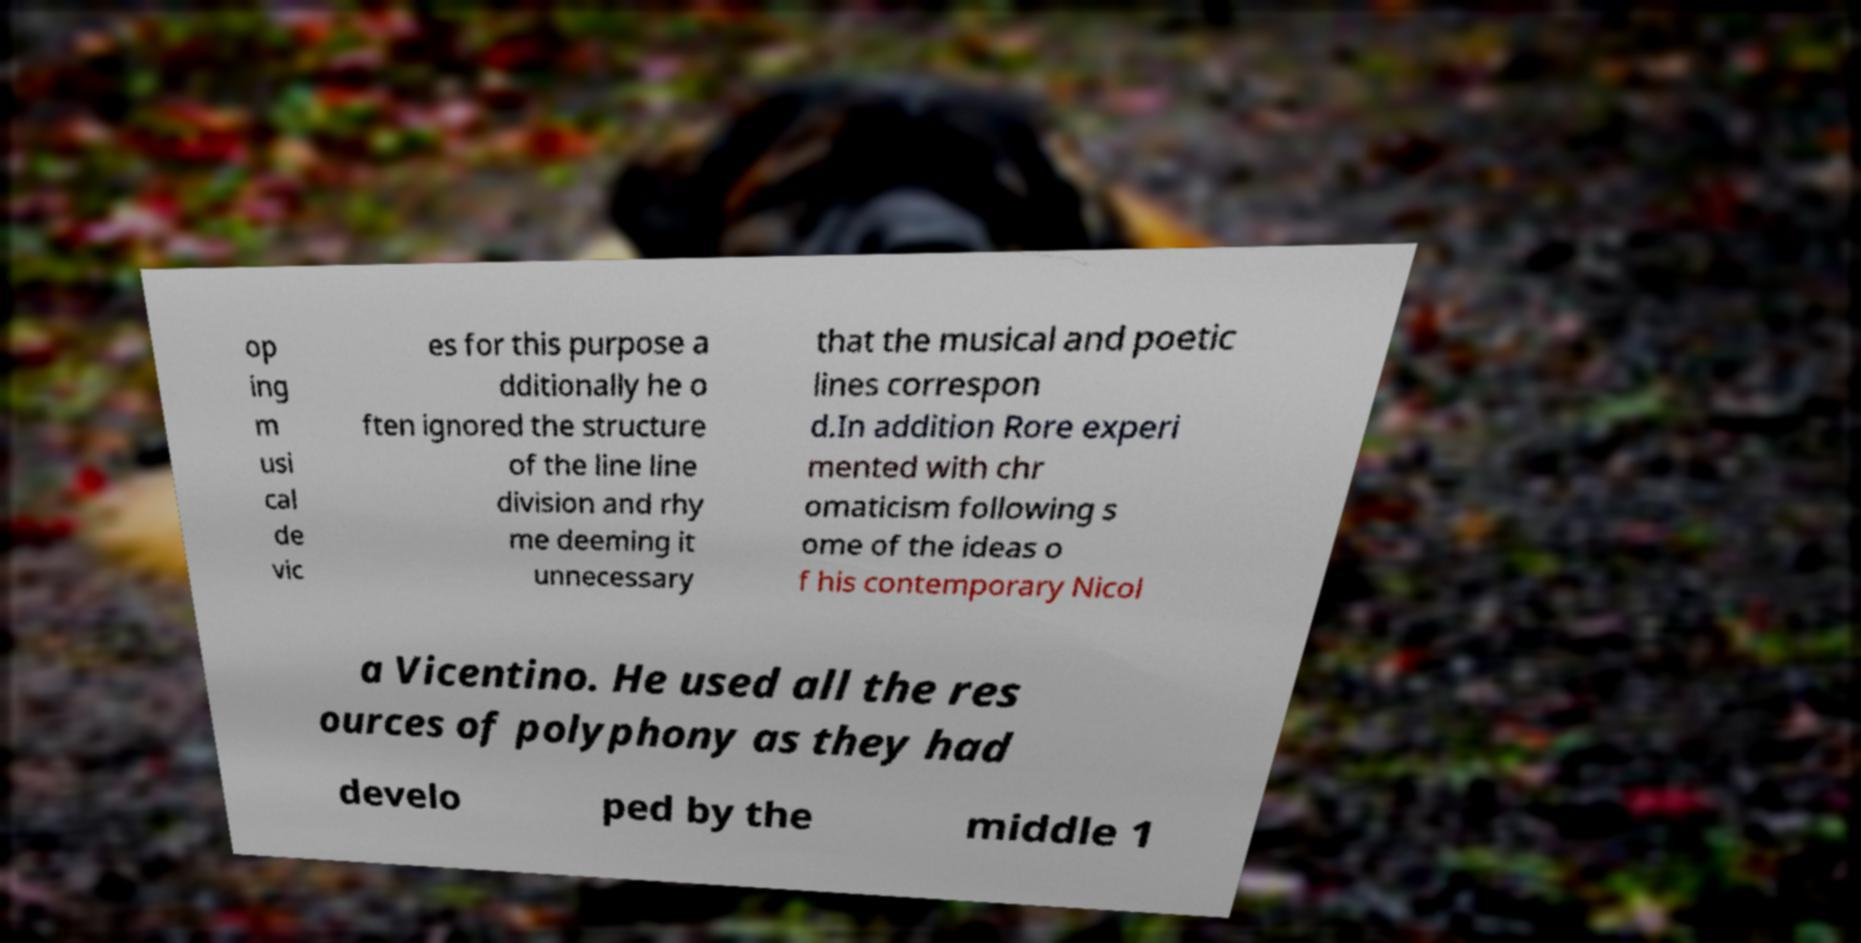What messages or text are displayed in this image? I need them in a readable, typed format. op ing m usi cal de vic es for this purpose a dditionally he o ften ignored the structure of the line line division and rhy me deeming it unnecessary that the musical and poetic lines correspon d.In addition Rore experi mented with chr omaticism following s ome of the ideas o f his contemporary Nicol a Vicentino. He used all the res ources of polyphony as they had develo ped by the middle 1 